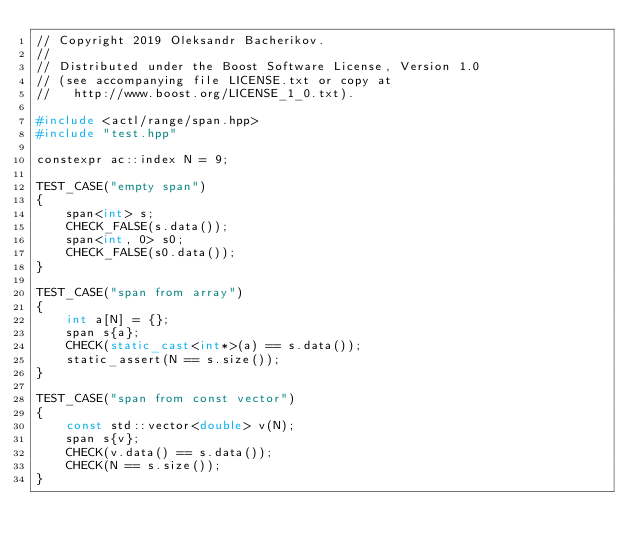<code> <loc_0><loc_0><loc_500><loc_500><_C++_>// Copyright 2019 Oleksandr Bacherikov.
//
// Distributed under the Boost Software License, Version 1.0
// (see accompanying file LICENSE.txt or copy at
//   http://www.boost.org/LICENSE_1_0.txt).

#include <actl/range/span.hpp>
#include "test.hpp"

constexpr ac::index N = 9;

TEST_CASE("empty span")
{
    span<int> s;
    CHECK_FALSE(s.data());
    span<int, 0> s0;
    CHECK_FALSE(s0.data());
}

TEST_CASE("span from array")
{
    int a[N] = {};
    span s{a};
    CHECK(static_cast<int*>(a) == s.data());
    static_assert(N == s.size());
}

TEST_CASE("span from const vector")
{
    const std::vector<double> v(N);
    span s{v};
    CHECK(v.data() == s.data());
    CHECK(N == s.size());
}
</code> 